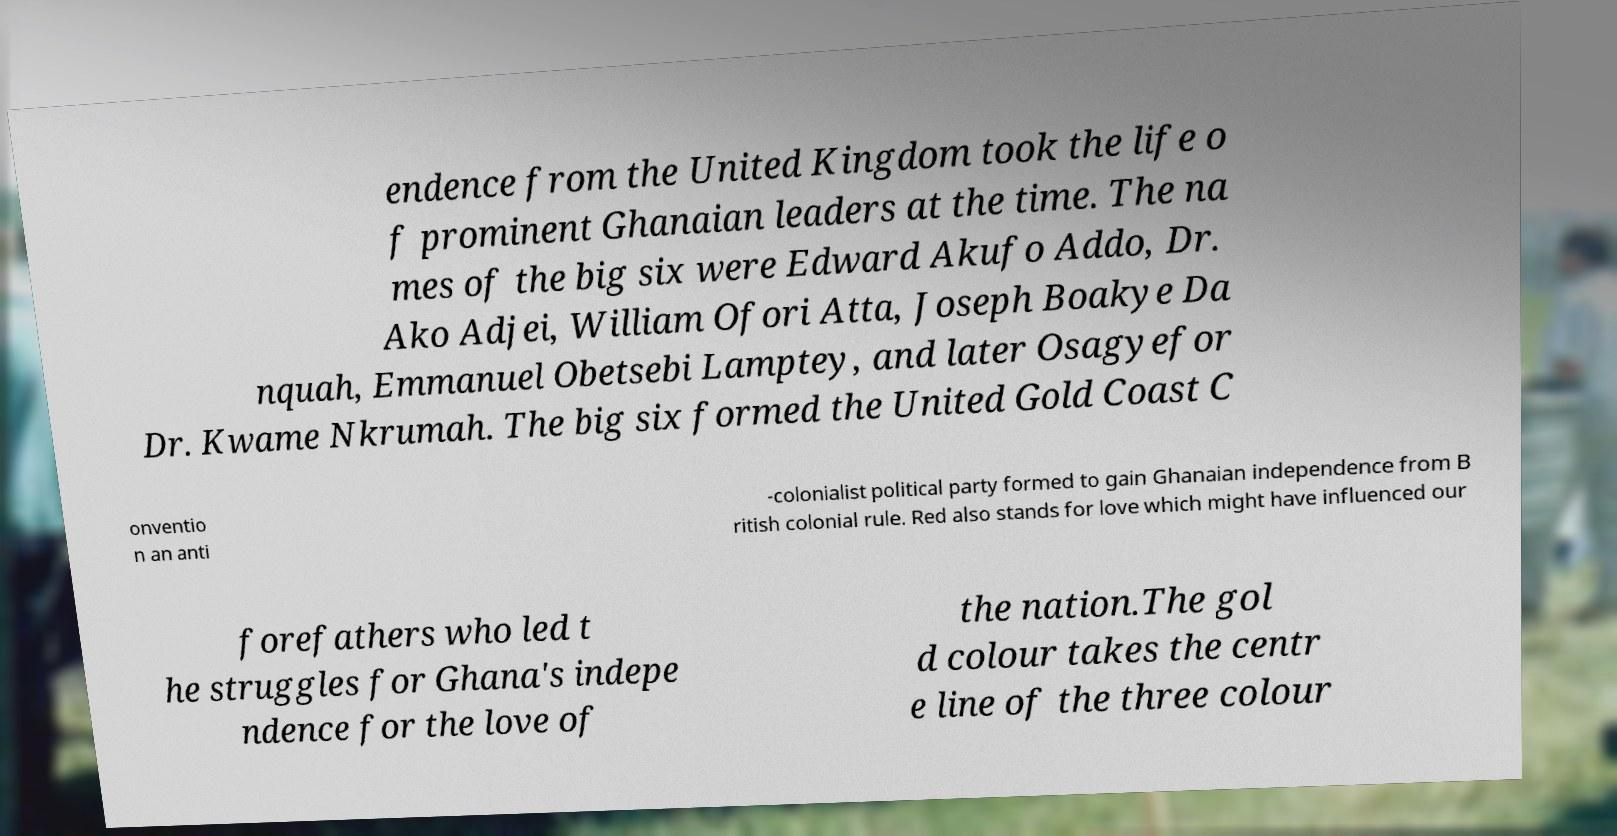I need the written content from this picture converted into text. Can you do that? endence from the United Kingdom took the life o f prominent Ghanaian leaders at the time. The na mes of the big six were Edward Akufo Addo, Dr. Ako Adjei, William Ofori Atta, Joseph Boakye Da nquah, Emmanuel Obetsebi Lamptey, and later Osagyefor Dr. Kwame Nkrumah. The big six formed the United Gold Coast C onventio n an anti -colonialist political party formed to gain Ghanaian independence from B ritish colonial rule. Red also stands for love which might have influenced our forefathers who led t he struggles for Ghana's indepe ndence for the love of the nation.The gol d colour takes the centr e line of the three colour 